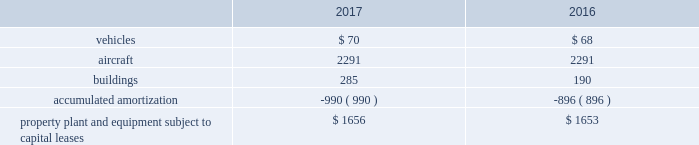United parcel service , inc .
And subsidiaries notes to consolidated financial statements floating-rate senior notes the floating-rate senior notes with principal amounts totaling $ 1.043 billion , bear interest at either one or three-month libor , less a spread ranging from 30 to 45 basis points .
The average interest rate for 2017 and 2016 was 0.74% ( 0.74 % ) and 0.21% ( 0.21 % ) , respectively .
These notes are callable at various times after 30 years at a stated percentage of par value , and putable by the note holders at various times after one year at a stated percentage of par value .
The notes have maturities ranging from 2049 through 2067 .
We classified the floating-rate senior notes that are putable by the note holder as a long-term liability , due to our intent and ability to refinance the debt if the put option is exercised by the note holder .
In march and november 2017 , we issued floating-rate senior notes in the principal amounts of $ 147 and $ 64 million , respectively , which are included in the $ 1.043 billion floating-rate senior notes described above .
These notes will bear interest at three-month libor less 30 and 35 basis points , respectively and mature in 2067 .
The remaining three floating-rate senior notes in the principal amounts of $ 350 , $ 400 and $ 500 million , bear interest at three-month libor , plus a spread ranging from 15 to 45 basis points .
The average interest rate for 2017 and 2016 was 0.50% ( 0.50 % ) and 0.0% ( 0.0 % ) , respectively .
These notes are not callable .
The notes have maturities ranging from 2021 through 2023 .
We classified the floating-rate senior notes that are putable by the note holder as a long-term liability , due to our intent and ability to refinance the debt if the put option is exercised by the note holder .
Capital lease obligations we have certain property , plant and equipment subject to capital leases .
Some of the obligations associated with these capital leases have been legally defeased .
The recorded value of our property , plant and equipment subject to capital leases is as follows as of december 31 ( in millions ) : .
These capital lease obligations have principal payments due at various dates from 2018 through 3005 .
Facility notes and bonds we have entered into agreements with certain municipalities to finance the construction of , or improvements to , facilities that support our u.s .
Domestic package and supply chain & freight operations in the united states .
These facilities are located around airport properties in louisville , kentucky ; dallas , texas ; and philadelphia , pennsylvania .
Under these arrangements , we enter into a lease or loan agreement that covers the debt service obligations on the bonds issued by the municipalities , as follows : 2022 bonds with a principal balance of $ 149 million issued by the louisville regional airport authority associated with our worldport facility in louisville , kentucky .
The bonds , which are due in january 2029 , bear interest at a variable rate , and the average interest rates for 2017 and 2016 were 0.83% ( 0.83 % ) and 0.37% ( 0.37 % ) , respectively .
2022 bonds with a principal balance of $ 42 million and due in november 2036 issued by the louisville regional airport authority associated with our air freight facility in louisville , kentucky .
The bonds bear interest at a variable rate , and the average interest rates for 2017 and 2016 were 0.80% ( 0.80 % ) and 0.36% ( 0.36 % ) , respectively .
2022 bonds with a principal balance of $ 29 million issued by the dallas / fort worth international airport facility improvement corporation associated with our dallas , texas airport facilities .
The bonds are due in may 2032 and bear interest at a variable rate , however the variable cash flows on the obligation have been swapped to a fixed 5.11% ( 5.11 % ) .
2022 in september 2015 , we entered into an agreement with the delaware county , pennsylvania industrial development authority , associated with our philadelphia , pennsylvania airport facilities , for bonds issued with a principal balance of $ 100 million .
These bonds , which are due september 2045 , bear interest at a variable rate .
The average interest rate for 2017 and 2016 was 0.78% ( 0.78 % ) and 0.40% ( 0.40 % ) , respectively. .
What was the percentage change in vehicles under capital lease from 2016 to 2017? 
Computations: ((70 - 68) / 68)
Answer: 0.02941. 